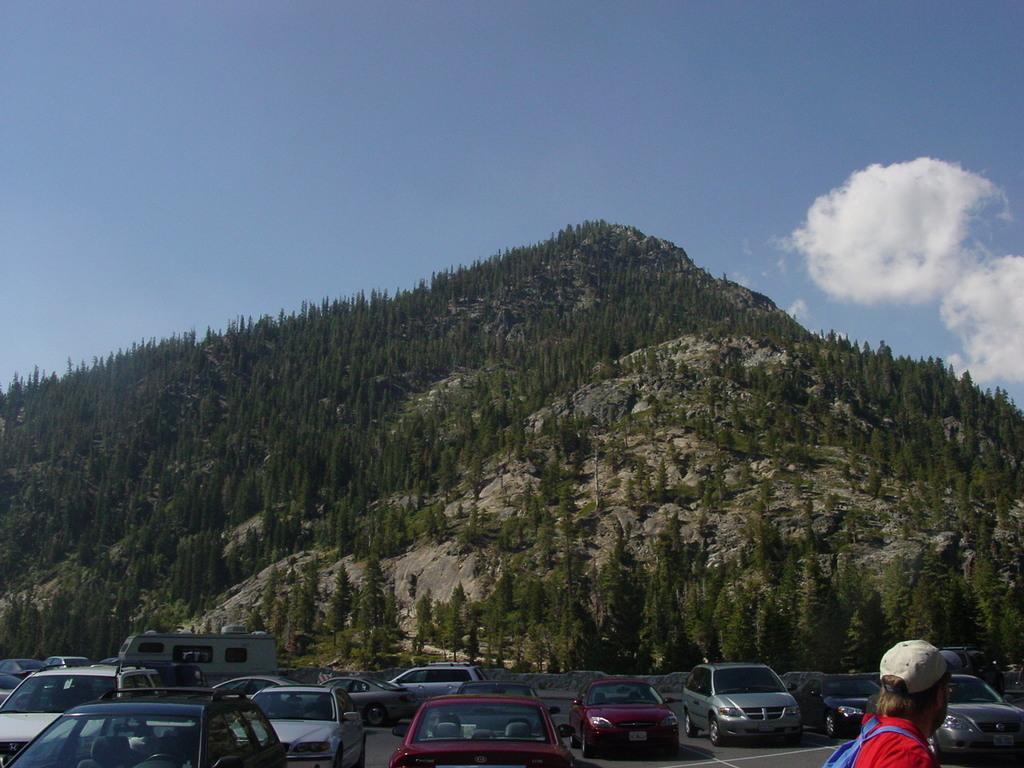Please provide a concise description of this image. Vehicles are on the road. Front this man wore bag and cap. Background there are a number of trees. Here we can see clouds.  